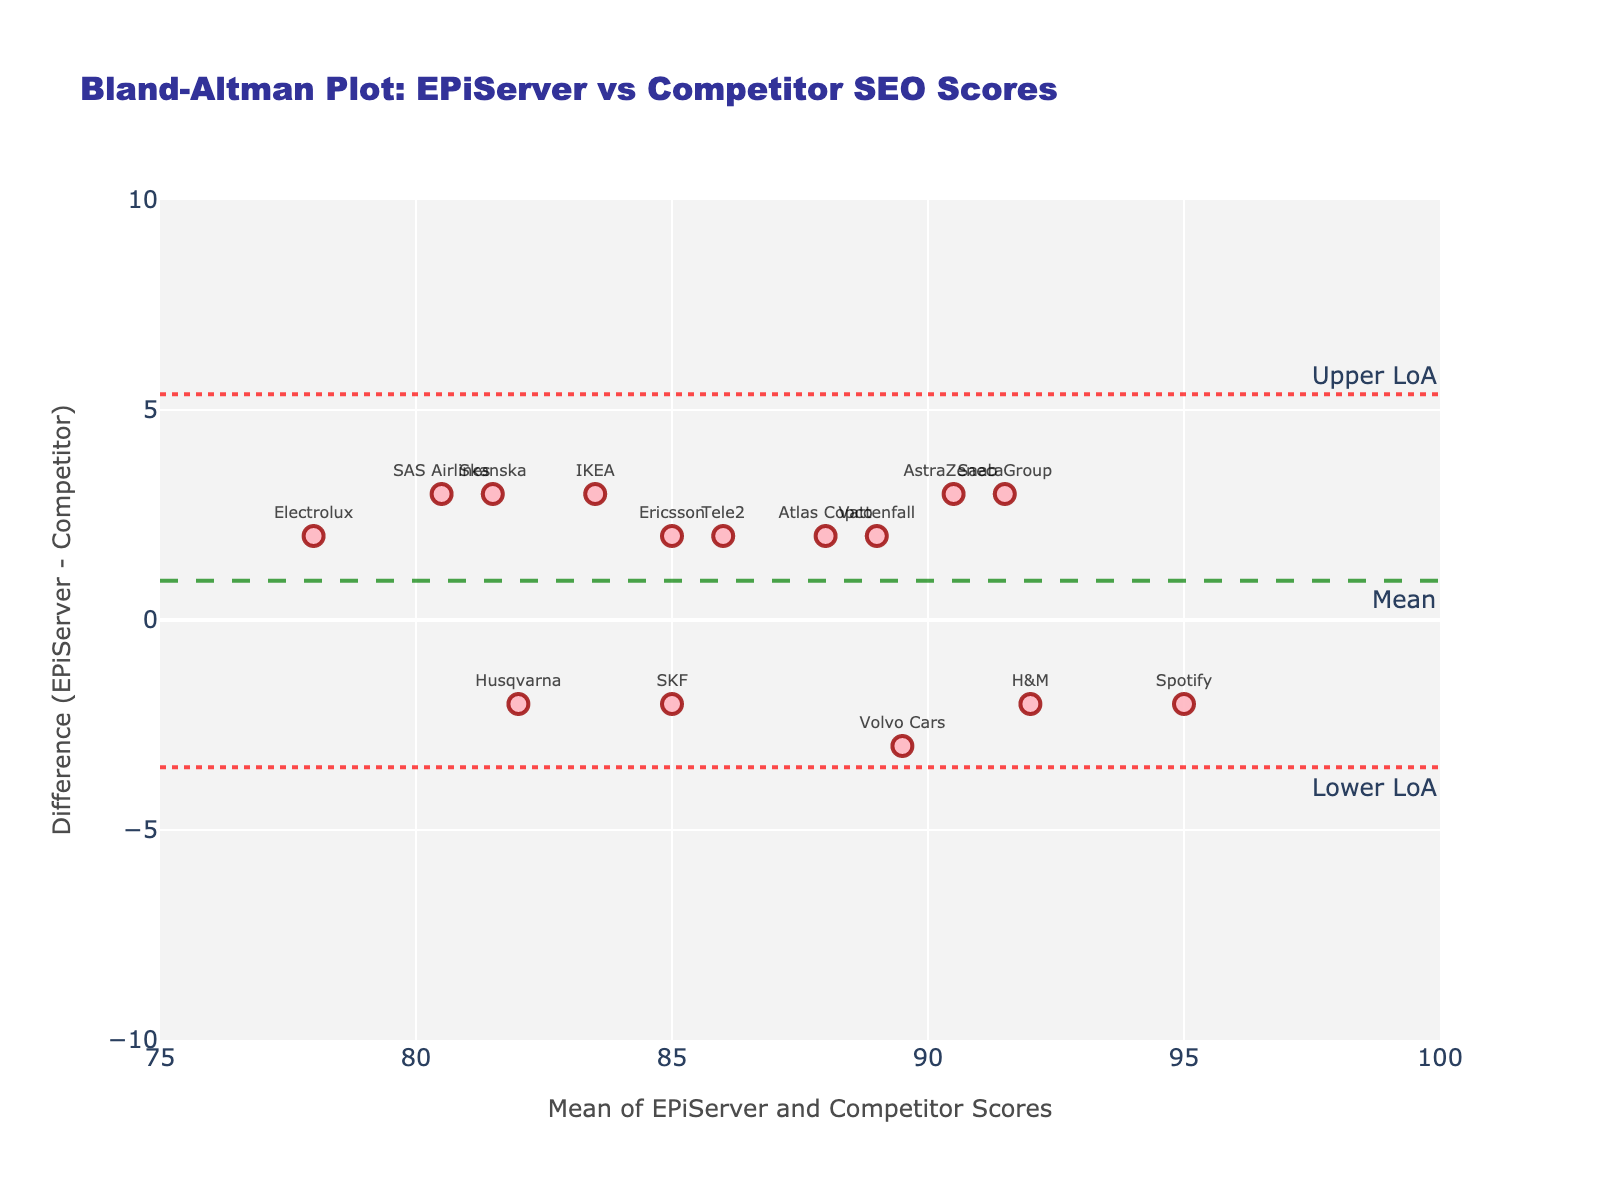What's the title of the plot? The title of the plot is usually displayed prominently at the top. In this figure, it reads "Bland-Altman Plot: EPiServer vs Competitor SEO Scores".
Answer: Bland-Altman Plot: EPiServer vs Competitor SEO Scores What does the X-axis represent? The X-axis title is provided below the axis. It states "Mean of EPiServer and Competitor Scores", which indicates that the X-axis represents the average SEO scores between EPiServer and the competitor.
Answer: Mean of EPiServer and Competitor Scores How many data points are there in the figure? Count the markers representing individual data points. Each marker corresponds to a pair of SEO scores for each site. You would find 15 markers based on the data provided.
Answer: 15 What is the Mean Difference line's approximate value? The Mean Difference line is typically shown as a dashed horizontal line, and its value is annotated on the plot. From the figure, the Mean Difference line is annotated at around 0.
Answer: 0 Which site has the highest mean score of EPiServer and Competitor Scores? To identify this, locate the marker farthest to the right on the X-axis. The text label next to this point will indicate the site. In this case, Spotify has the highest mean score.
Answer: Spotify What is the range of the Y-axis? The Y-axis range is usually indicated along the axis with tick marks. It ranges from -10 to 10, as seen on the plot.
Answer: -10 to 10 What is the site with the greatest negative difference in SEO scores? The greatest negative difference can be found by locating the point lowest on the Y-axis. Based on the data, SAS Airlines has the largest negative difference (EPiServer score is lower than Competitor by 3 points).
Answer: SAS Airlines Are there more sites where EPiServer scores higher than the competitor, or more where the competitor scores higher? Count the number of points above and below the zero line on the Y-axis. Points above signify EPiServer scored higher, and points below signify Competitor scored higher. There are more points below, indicating the competitor scores higher in more cases.
Answer: Competitor scores higher more often What are the upper and lower limits of agreement? The upper and lower limits of agreement are typically shown as dotted horizontal lines, and their values are annotated on the plot. The upper limit is approximately at +3, and the lower limit is approximately at -3.
Answer: +3 and -3 What does a point above the zero line in this plot indicate? Points above the zero line on the Y-axis indicate that the EPiServer SEO score is higher than the Competitor SEO score for those sites. This is derived from the difference calculation (EPiServer - Competitor).
Answer: EPiServer score is higher 